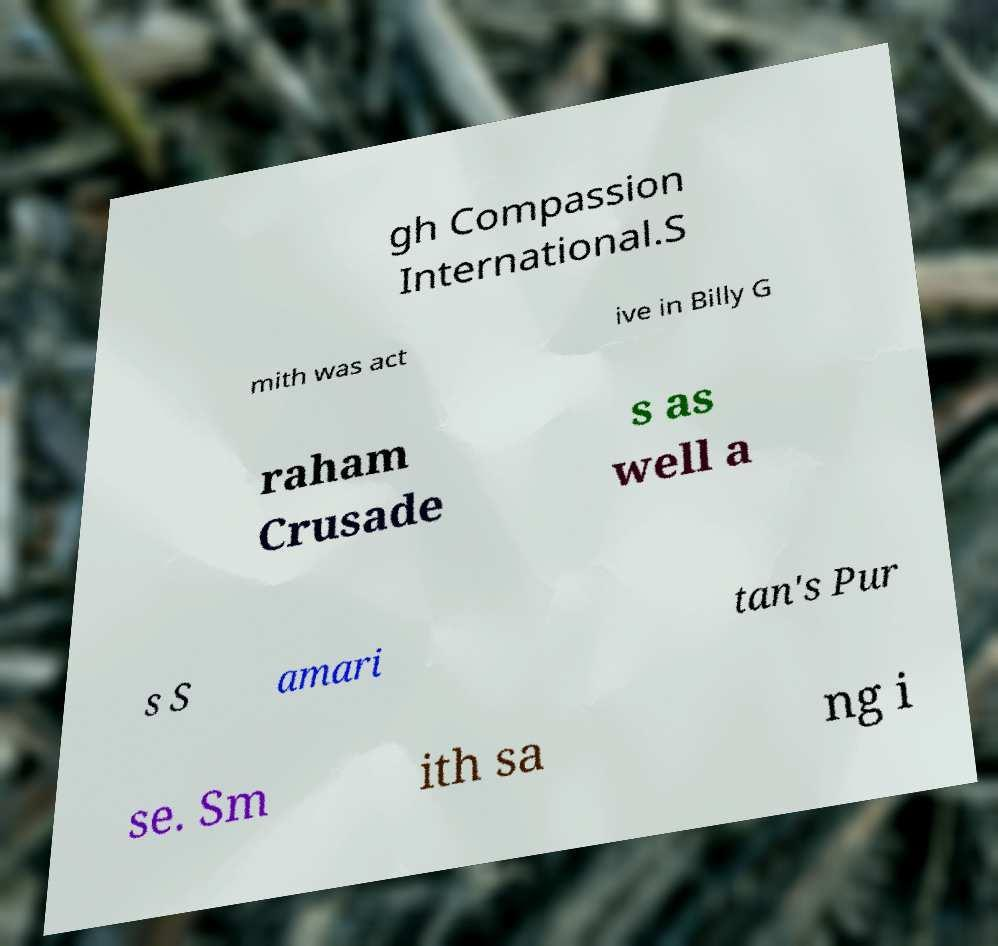Please read and relay the text visible in this image. What does it say? gh Compassion International.S mith was act ive in Billy G raham Crusade s as well a s S amari tan's Pur se. Sm ith sa ng i 